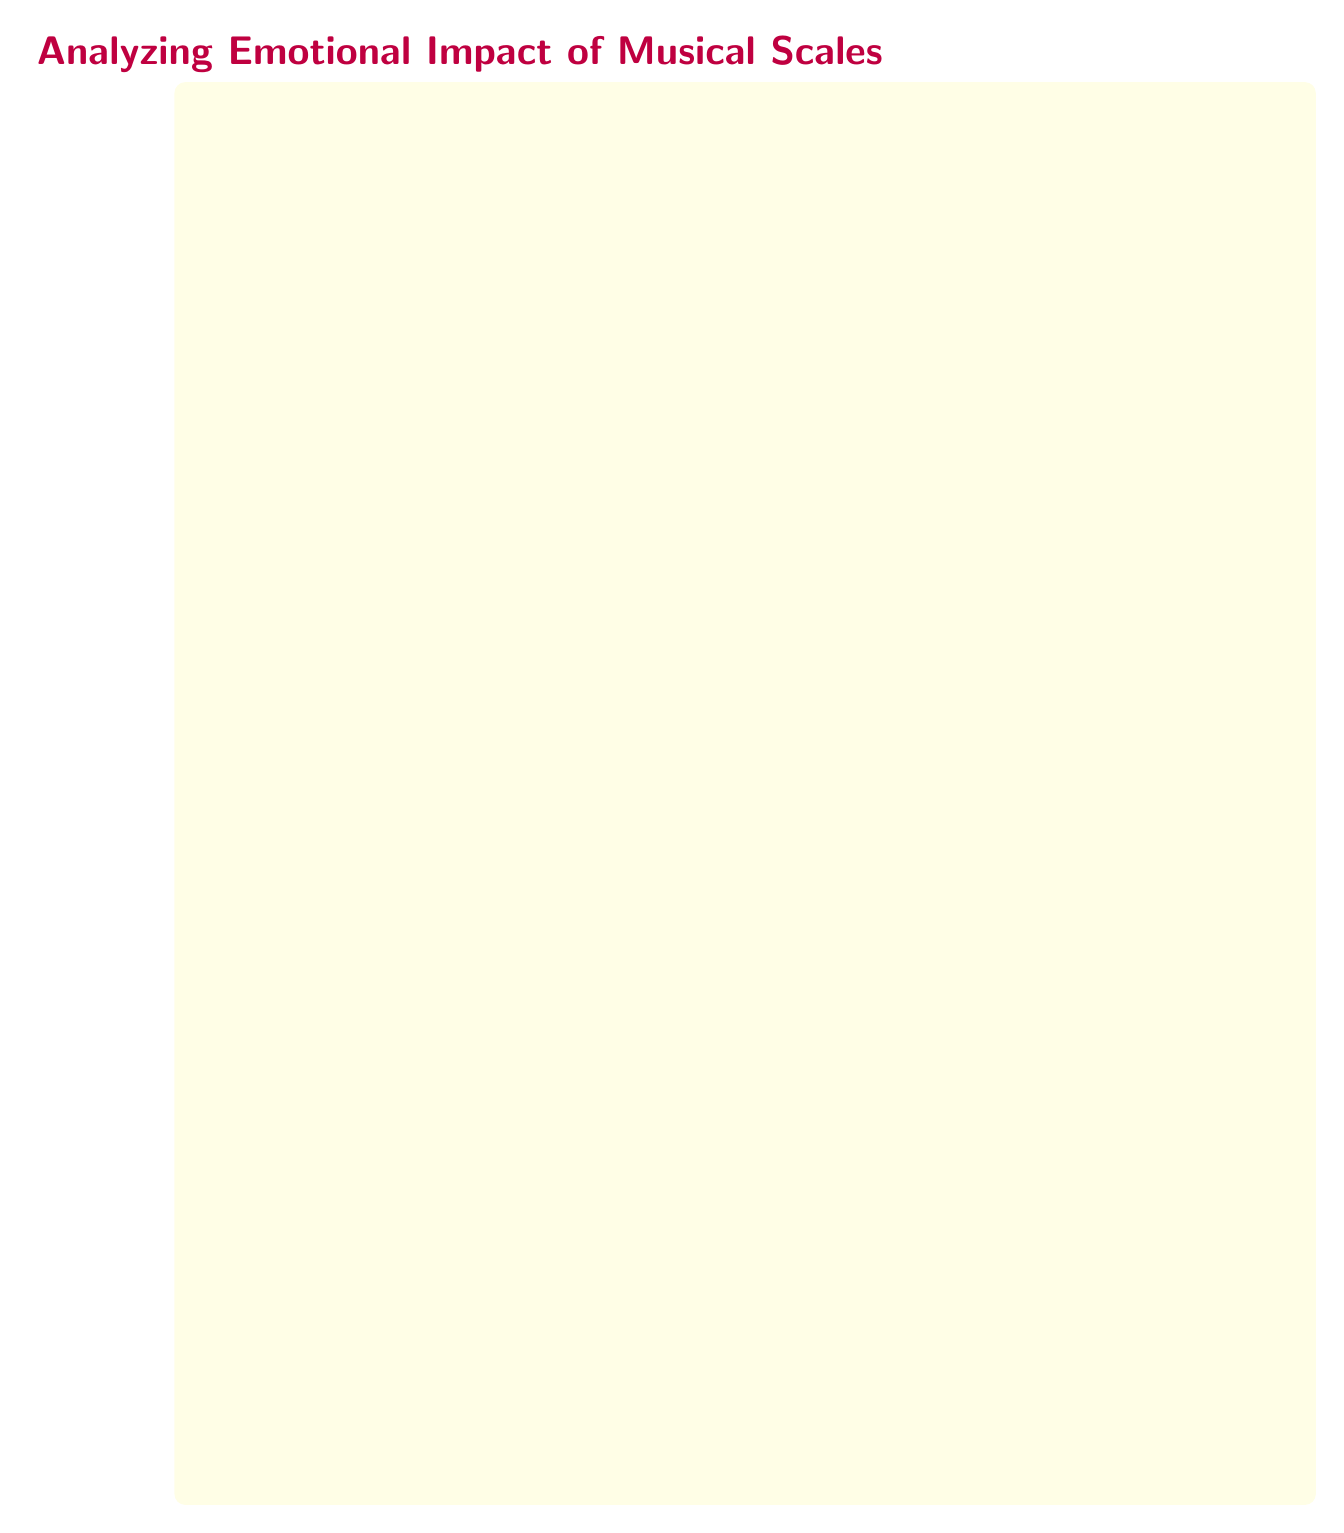What is the title of the diagram? The title is prominently displayed at the top of the diagram, indicating the main focus of the diagram. It reads "Analyzing Emotional Impact of Musical Scales."
Answer: Analyzing Emotional Impact of Musical Scales How many nodes are there in the diagram? By counting each rectangular box in the diagram, we find a total of seven nodes. Each node represents a different stage in the machine learning process.
Answer: 7 What is the output of the model training node? The output of the model training node is directed to the next node, labeled "Model Evaluation," which measures how well the model performs. This indicates the model is being assessed.
Answer: Output What is the input to the prediction node? The input to the prediction node comes from the previous node, "Model Evaluation," which signifies that the evaluated model's results are being used for prediction purposes.
Answer: Predicts What type of data is gathered in the first node? The first node specifies that audio recordings are gathered, indicating that the data collection process focuses on musical audio data and it is particularly noted that it includes various scales.
Answer: audio recordings in different scales Which nodes are combined at the training data preparation stage? At the training data preparation stage, features extracted in the second node and emotional responses tagged in the third node are combined to create a comprehensive dataset for training the model.
Answer: features and annotations What machine learning algorithms are mentioned for training the model? The diagram lists "SVM" and "Random Forest" as the algorithms used in the model training node, indicating common techniques in machine learning for classification tasks.
Answer: SVM, Random Forest What is the purpose of the emotion annotation node? The purpose of the emotion annotation node is to tag the audio recordings with emotional responses, ensuring that each musical piece is associated with how it makes listeners feel, which is crucial for the analysis.
Answer: Tag recordings with emotional responses How does the flow progress from data collection to prediction? The flow begins with data collection, leading to feature extraction, emotion annotation, which then prepares training data, followed by model training, evaluation, and ending with the prediction of emotions from new musical scales.
Answer: Data collection to prediction through several processing stages 